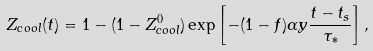<formula> <loc_0><loc_0><loc_500><loc_500>Z _ { c o o l } ( t ) = 1 - ( 1 - Z _ { c o o l } ^ { 0 } ) \exp \left [ - ( 1 - f ) \alpha y \frac { t - t _ { s } } { \tau _ { * } } \right ] ,</formula> 